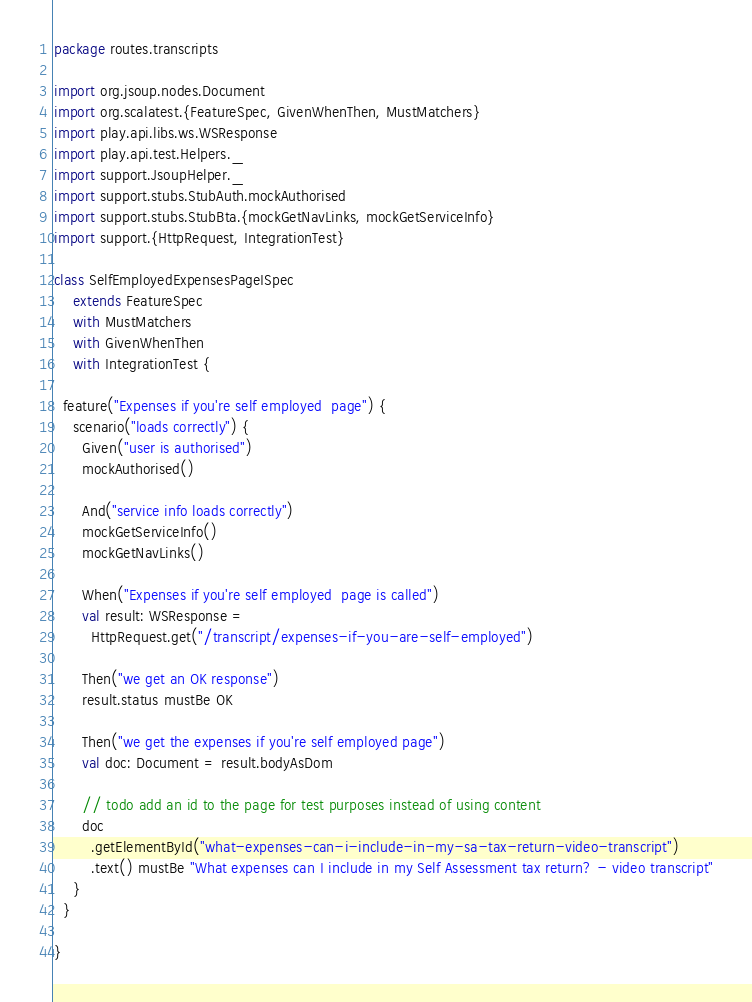Convert code to text. <code><loc_0><loc_0><loc_500><loc_500><_Scala_>package routes.transcripts

import org.jsoup.nodes.Document
import org.scalatest.{FeatureSpec, GivenWhenThen, MustMatchers}
import play.api.libs.ws.WSResponse
import play.api.test.Helpers._
import support.JsoupHelper._
import support.stubs.StubAuth.mockAuthorised
import support.stubs.StubBta.{mockGetNavLinks, mockGetServiceInfo}
import support.{HttpRequest, IntegrationTest}

class SelfEmployedExpensesPageISpec
    extends FeatureSpec
    with MustMatchers
    with GivenWhenThen
    with IntegrationTest {

  feature("Expenses if you're self employed  page") {
    scenario("loads correctly") {
      Given("user is authorised")
      mockAuthorised()

      And("service info loads correctly")
      mockGetServiceInfo()
      mockGetNavLinks()

      When("Expenses if you're self employed  page is called")
      val result: WSResponse =
        HttpRequest.get("/transcript/expenses-if-you-are-self-employed")

      Then("we get an OK response")
      result.status mustBe OK

      Then("we get the expenses if you're self employed page")
      val doc: Document = result.bodyAsDom

      // todo add an id to the page for test purposes instead of using content
      doc
        .getElementById("what-expenses-can-i-include-in-my-sa-tax-return-video-transcript")
        .text() mustBe "What expenses can I include in my Self Assessment tax return? - video transcript"
    }
  }

}
</code> 